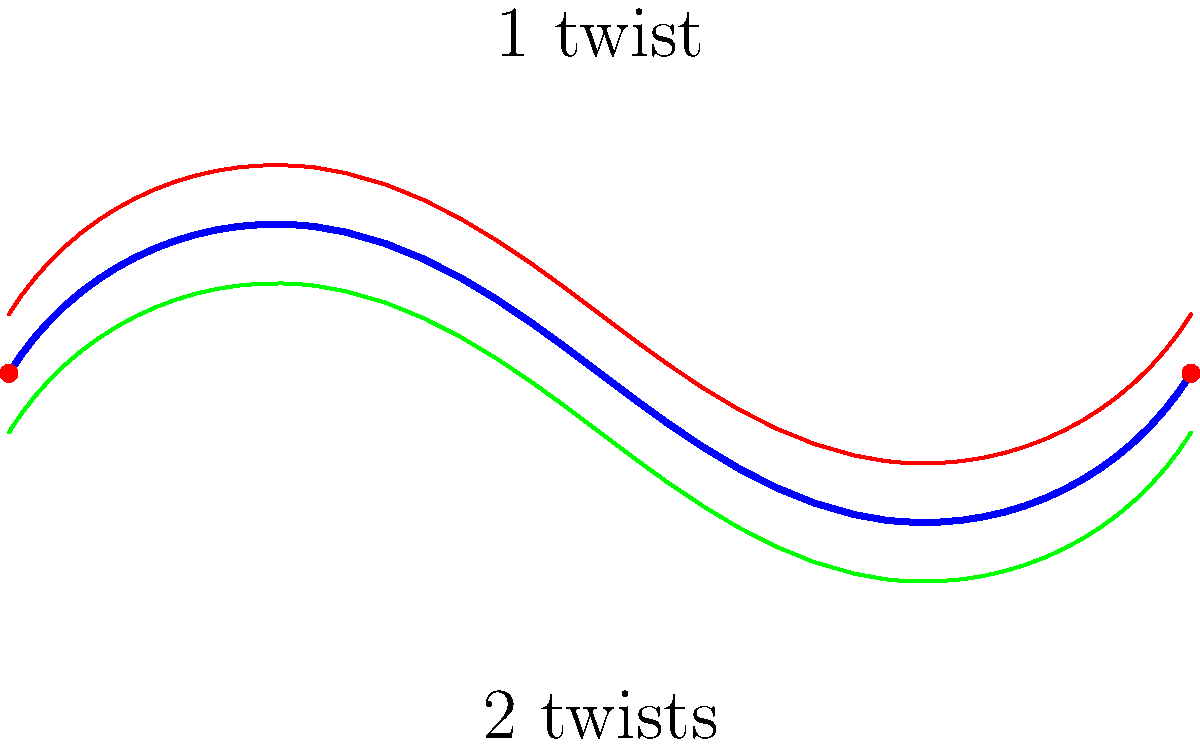As an artist exploring topological forms, you're creating Möbius strips with different numbers of twists. How does the number of twists affect the strip's properties? Specifically, what happens to the number of sides and edges when you create a Möbius strip with an odd number of half-twists compared to an even number? Let's explore this step-by-step:

1. A standard Möbius strip has one half-twist (180°):
   - It has one side and one edge.
   - If you trace along the surface, you return to the starting point after traversing the entire strip once.

2. For strips with odd numbers of half-twists (1, 3, 5, etc.):
   - They all behave like the standard Möbius strip.
   - They have one side and one edge.
   - A complete traverse returns you to the starting point after one loop.

3. For strips with even numbers of half-twists (2, 4, 6, etc.):
   - They behave differently from odd-twisted strips.
   - They have two sides and two edges.
   - A complete traverse returns you to the starting point after two loops.

4. Mathematical explanation:
   - Let $n$ be the number of half-twists.
   - For odd $n$: The strip has $\frac{n+1}{2}$ full twists, which is always a non-integer.
   - For even $n$: The strip has $\frac{n}{2}$ full twists, which is always an integer.

5. Artistic perspective:
   - Odd-twisted strips create a continuous, seamless surface, embodying unity and infinity.
   - Even-twisted strips create a disconnected feel, representing duality or separation.

Therefore, the number of twists fundamentally changes the topological properties of the strip, affecting both its mathematical characteristics and its artistic interpretation.
Answer: Odd twists: 1 side, 1 edge. Even twists: 2 sides, 2 edges. 